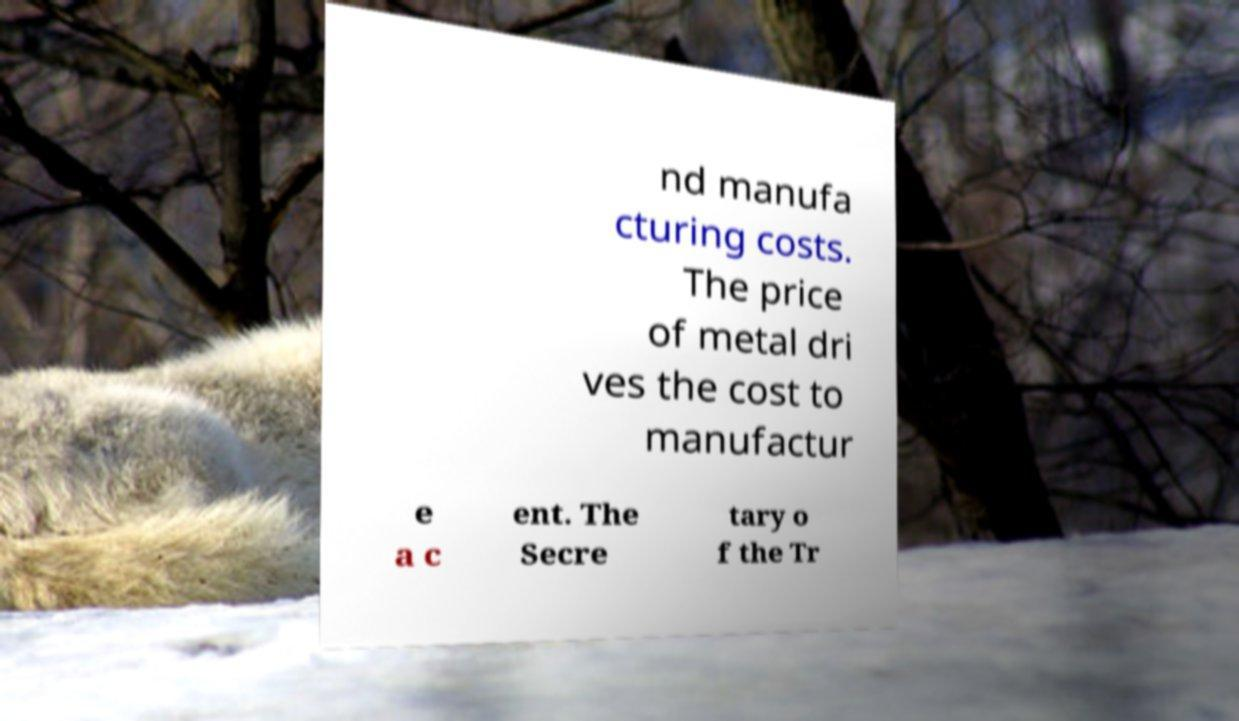Could you assist in decoding the text presented in this image and type it out clearly? nd manufa cturing costs. The price of metal dri ves the cost to manufactur e a c ent. The Secre tary o f the Tr 